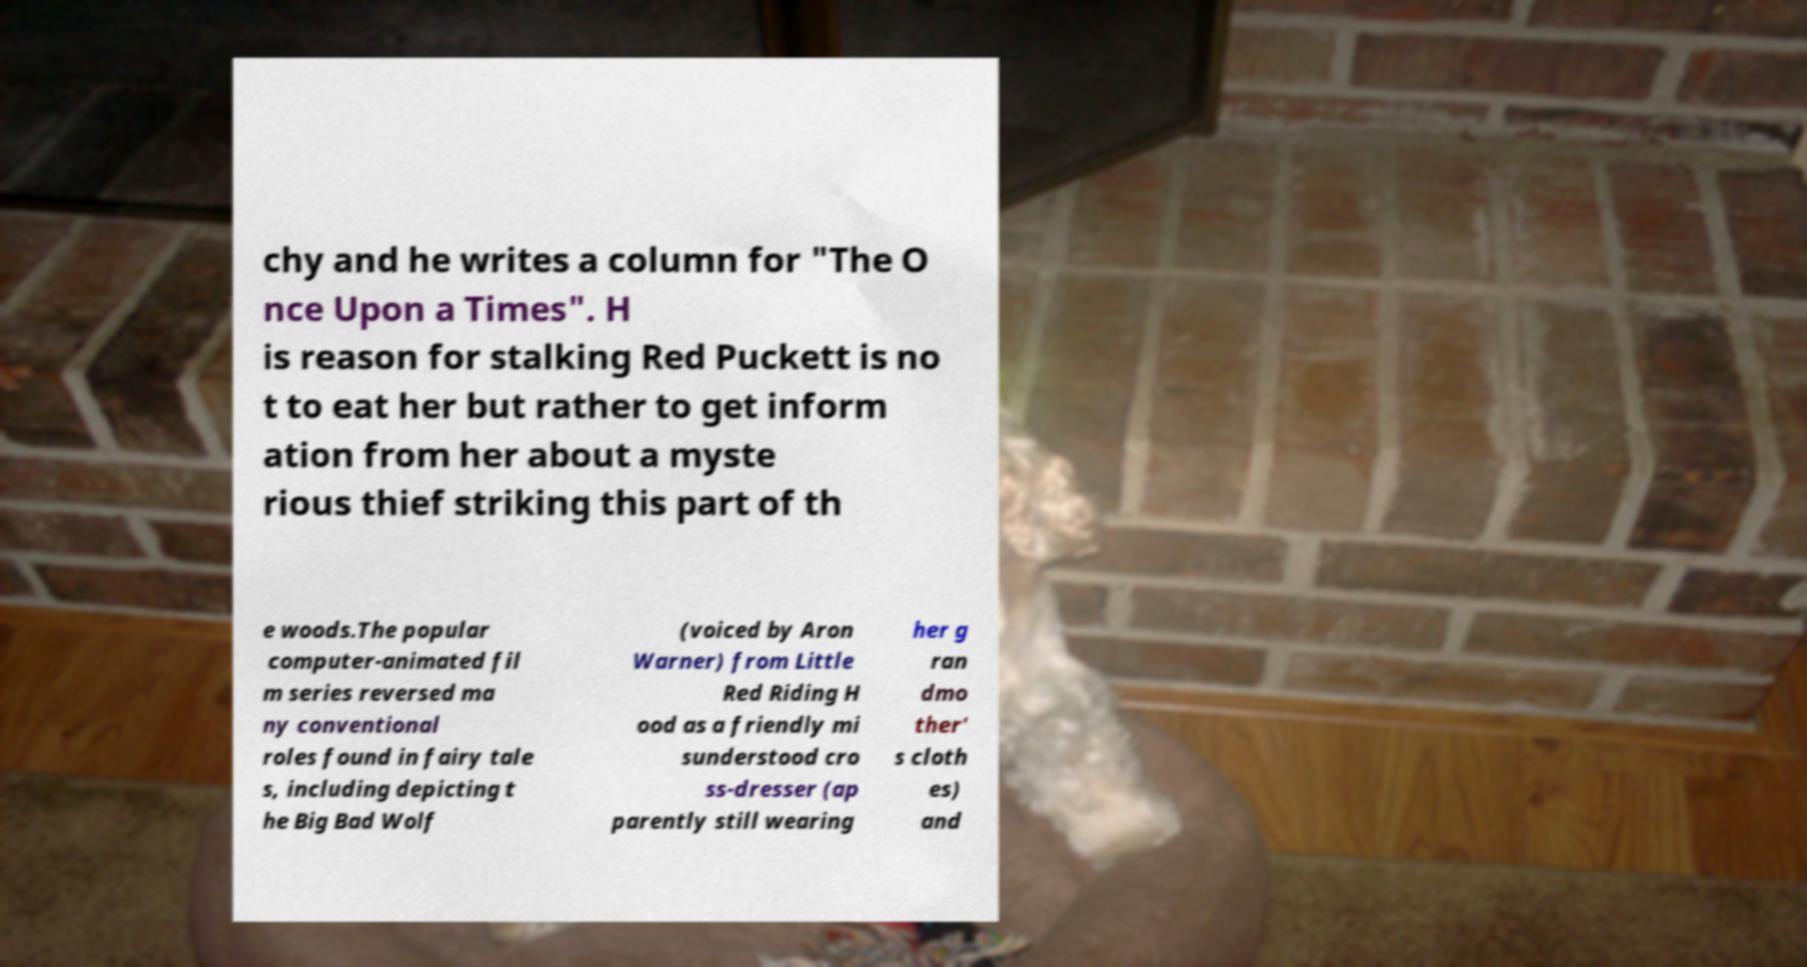There's text embedded in this image that I need extracted. Can you transcribe it verbatim? chy and he writes a column for "The O nce Upon a Times". H is reason for stalking Red Puckett is no t to eat her but rather to get inform ation from her about a myste rious thief striking this part of th e woods.The popular computer-animated fil m series reversed ma ny conventional roles found in fairy tale s, including depicting t he Big Bad Wolf (voiced by Aron Warner) from Little Red Riding H ood as a friendly mi sunderstood cro ss-dresser (ap parently still wearing her g ran dmo ther' s cloth es) and 